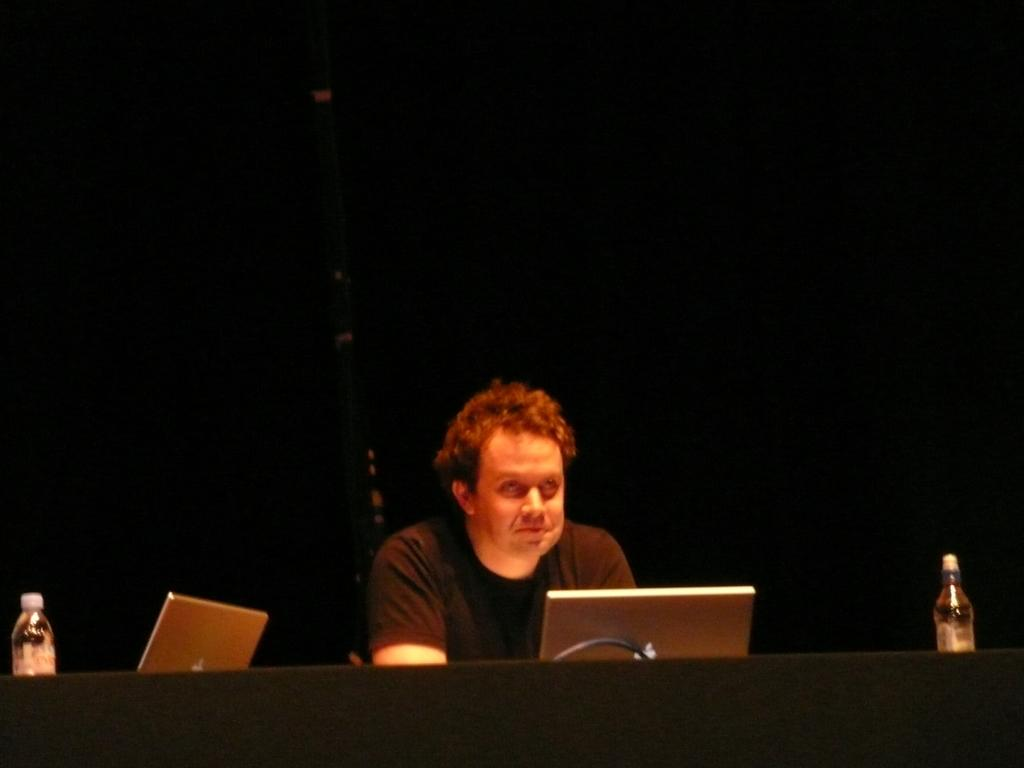What is the person at the desk doing in the image? The provided facts do not specify what the person is doing, but we can see that they are at a desk. What items are on the desk in the image? There are water bottles and at least one laptop on the desk. What can be seen in the background of the image? There is a wall in the background of the image. Are there any fairies flying around the person at the desk in the image? There are no fairies present in the image. Can you see a bird perched on the laptop in the image? There is no bird visible in the image. 